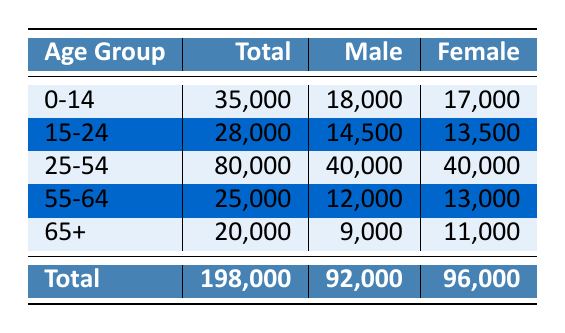What is the total population of Nantes? The total population is listed in the last row of the table under the "Total" column, which states that the population is 198,000.
Answer: 198,000 How many males are there in the age group 0-14? The number of males in the age group 0-14 is found in the corresponding row under the "Male" column, which shows 18,000.
Answer: 18,000 What is the gender ratio in Nantes? The gender ratio can be derived from the totals of males and females, which are 92,000 males and 96,000 females as shown at the bottom of the table.
Answer: 92,000 males and 96,000 females Which age group has the highest total population? By comparing the "Total" column for each age group, the group 25-54 has the highest total population, which is 80,000.
Answer: 25-54 What is the difference in the number of females between the age groups 55-64 and 65+? The number of females in the 55-64 age group is 13,000 and in the 65+ age group is 11,000. The difference is calculated as 13,000 - 11,000 = 2,000.
Answer: 2,000 What is the total number of people in the 15-24 and 25-54 age groups combined? To find this total, add the totals for the two age groups: 28,000 (15-24) + 80,000 (25-54) = 108,000.
Answer: 108,000 Is there a larger female population than male population in Nantes? By comparing the total males (92,000) and females (96,000) from the bottom row, we see that females outnumber males.
Answer: Yes What percentage of the total population is made up of the 0-14 age group? The percentage can be calculated by dividing the number of people in the 0-14 age group (35,000) by the total population (198,000), then multiplying by 100: (35,000 / 198,000) * 100 ≈ 17.68%.
Answer: Approximately 17.68% What is the average number of males across all age groups? First, sum the number of males for each age group: 18,000 + 14,500 + 40,000 + 12,000 + 9,000 = 93,500. Then divide by 5 (the number of age groups) to get the average: 93,500 / 5 = 18,700.
Answer: 18,700 Which age group has the lowest total population? By looking at the "Total" column, the age group 15-24 has the lowest population total, which is 28,000.
Answer: 15-24 